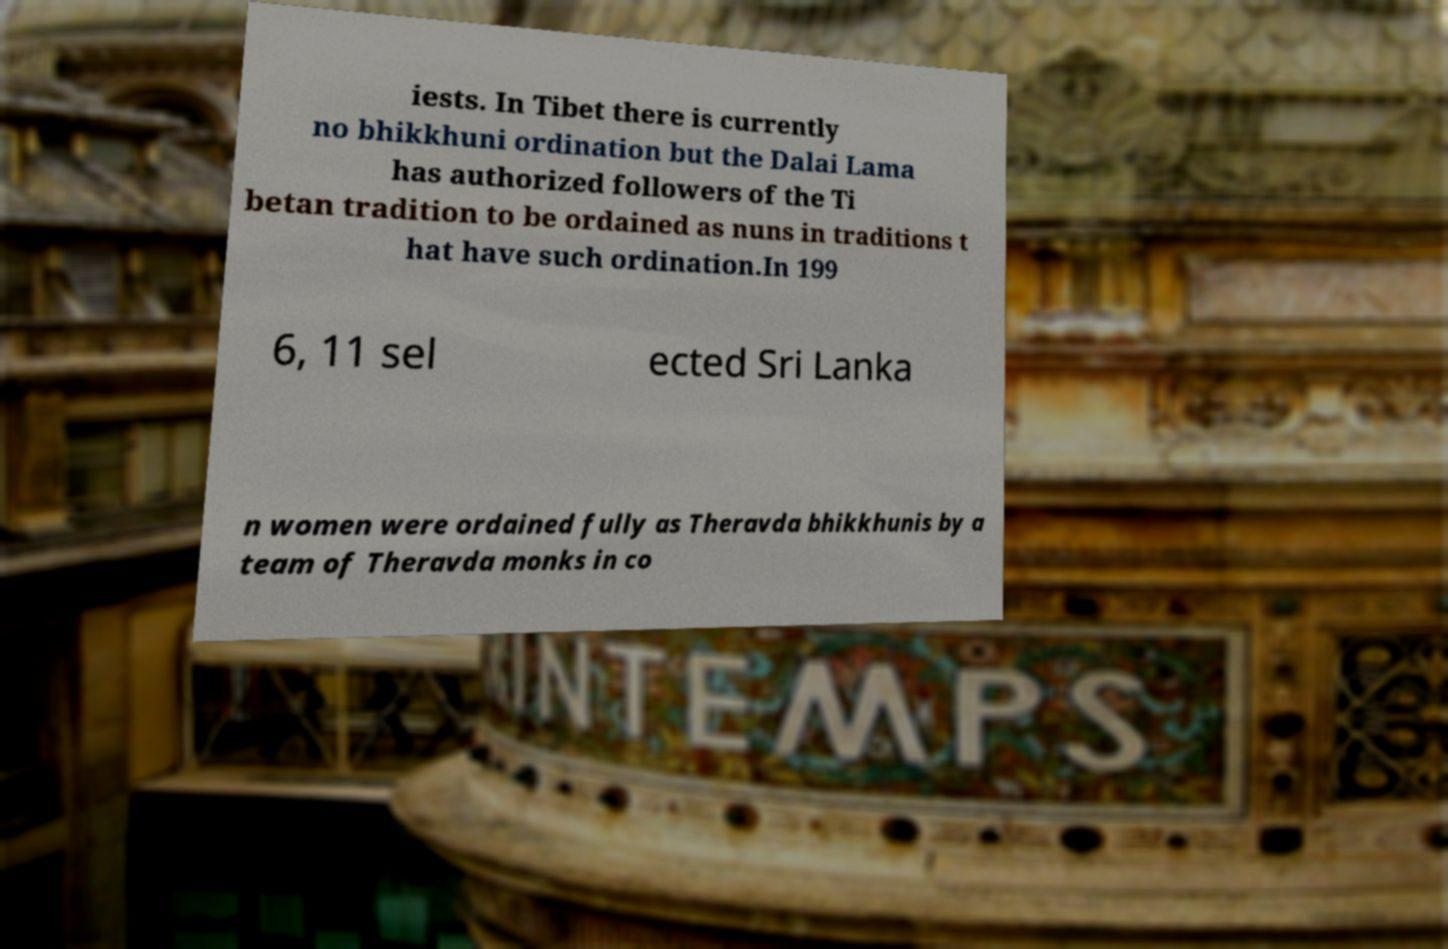Can you accurately transcribe the text from the provided image for me? iests. In Tibet there is currently no bhikkhuni ordination but the Dalai Lama has authorized followers of the Ti betan tradition to be ordained as nuns in traditions t hat have such ordination.In 199 6, 11 sel ected Sri Lanka n women were ordained fully as Theravda bhikkhunis by a team of Theravda monks in co 